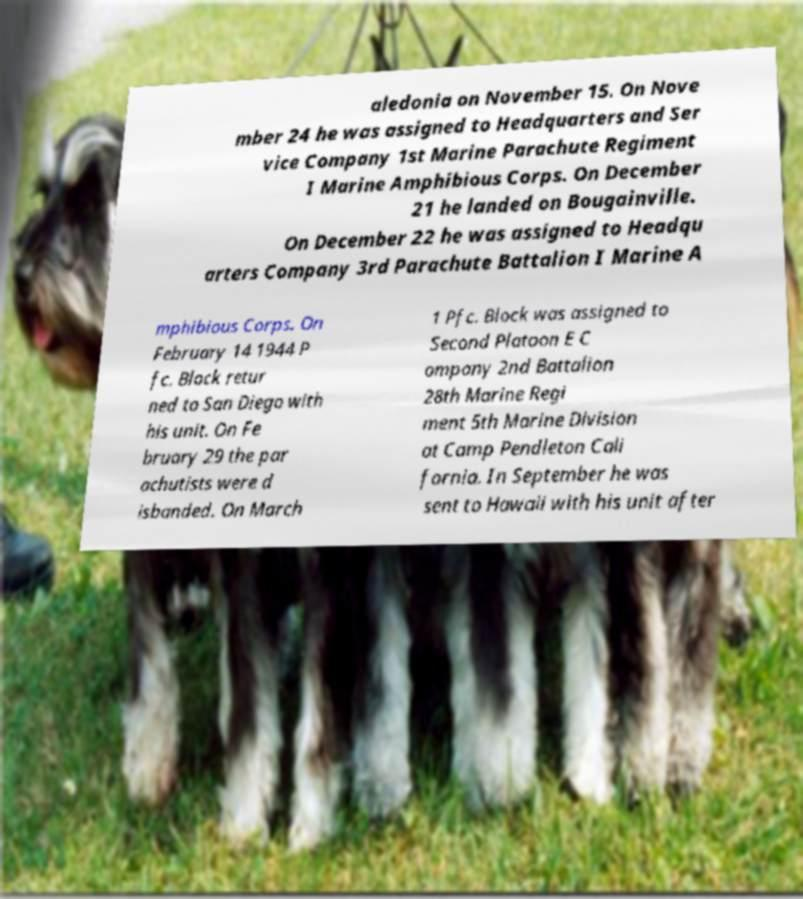Please read and relay the text visible in this image. What does it say? aledonia on November 15. On Nove mber 24 he was assigned to Headquarters and Ser vice Company 1st Marine Parachute Regiment I Marine Amphibious Corps. On December 21 he landed on Bougainville. On December 22 he was assigned to Headqu arters Company 3rd Parachute Battalion I Marine A mphibious Corps. On February 14 1944 P fc. Block retur ned to San Diego with his unit. On Fe bruary 29 the par achutists were d isbanded. On March 1 Pfc. Block was assigned to Second Platoon E C ompany 2nd Battalion 28th Marine Regi ment 5th Marine Division at Camp Pendleton Cali fornia. In September he was sent to Hawaii with his unit after 